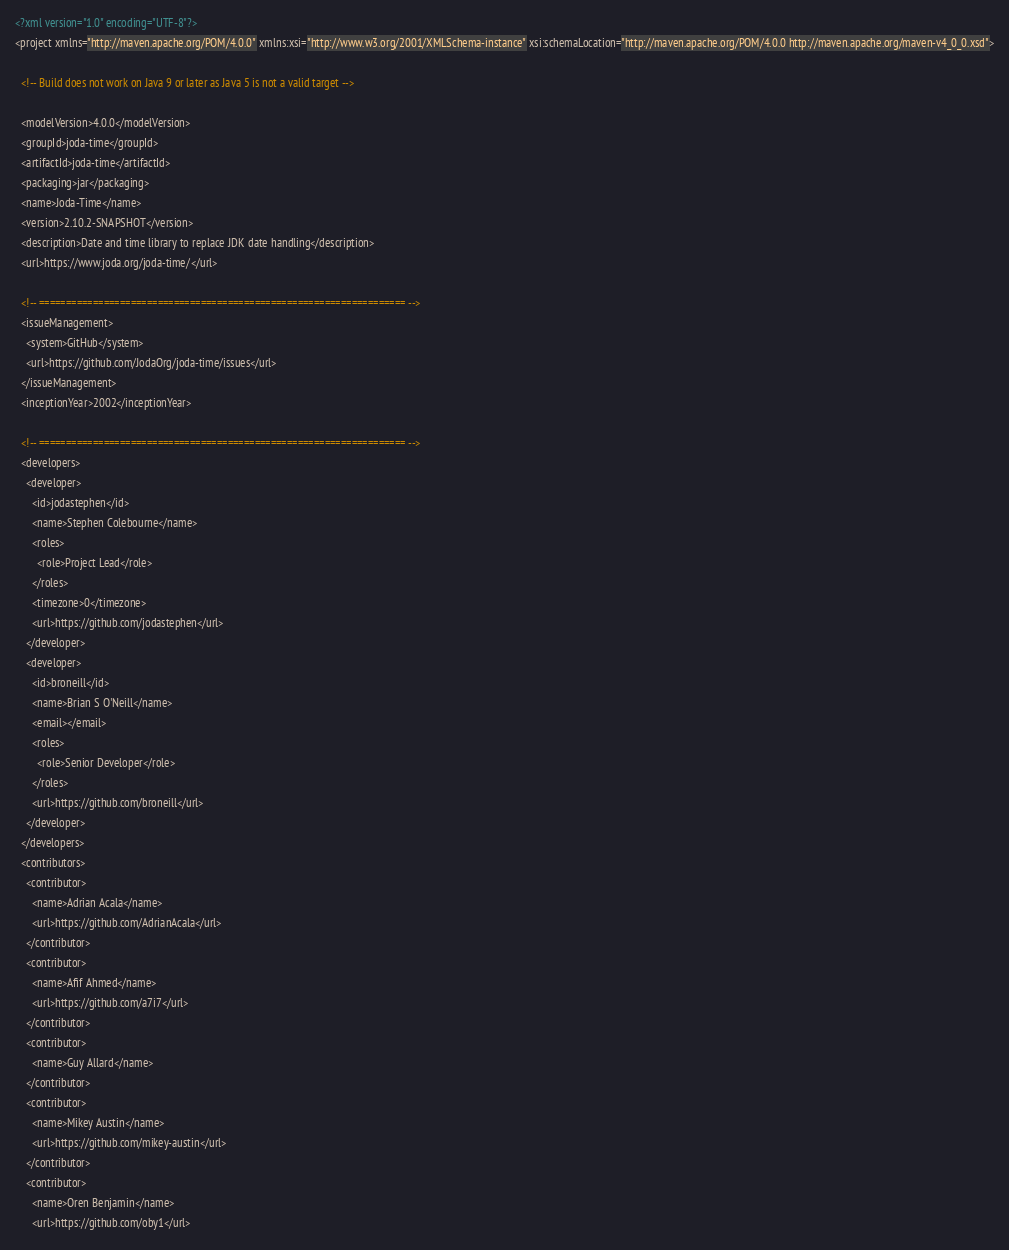<code> <loc_0><loc_0><loc_500><loc_500><_XML_><?xml version="1.0" encoding="UTF-8"?>
<project xmlns="http://maven.apache.org/POM/4.0.0" xmlns:xsi="http://www.w3.org/2001/XMLSchema-instance" xsi:schemaLocation="http://maven.apache.org/POM/4.0.0 http://maven.apache.org/maven-v4_0_0.xsd">

  <!-- Build does not work on Java 9 or later as Java 5 is not a valid target -->

  <modelVersion>4.0.0</modelVersion>
  <groupId>joda-time</groupId>
  <artifactId>joda-time</artifactId>
  <packaging>jar</packaging>
  <name>Joda-Time</name>
  <version>2.10.2-SNAPSHOT</version>
  <description>Date and time library to replace JDK date handling</description>
  <url>https://www.joda.org/joda-time/</url>

  <!-- ==================================================================== -->
  <issueManagement>
    <system>GitHub</system>
    <url>https://github.com/JodaOrg/joda-time/issues</url>
  </issueManagement>
  <inceptionYear>2002</inceptionYear>

  <!-- ==================================================================== -->
  <developers>
    <developer>
      <id>jodastephen</id>
      <name>Stephen Colebourne</name>
      <roles>
        <role>Project Lead</role>
      </roles>
      <timezone>0</timezone>
      <url>https://github.com/jodastephen</url>
    </developer>
    <developer>
      <id>broneill</id>
      <name>Brian S O'Neill</name>
      <email></email>
      <roles>
        <role>Senior Developer</role>
      </roles>
      <url>https://github.com/broneill</url>
    </developer>
  </developers>
  <contributors>
    <contributor>
      <name>Adrian Acala</name>
      <url>https://github.com/AdrianAcala</url>
    </contributor>
    <contributor>
      <name>Afif Ahmed</name>
      <url>https://github.com/a7i7</url>
    </contributor>
    <contributor>
      <name>Guy Allard</name>
    </contributor>
    <contributor>
      <name>Mikey Austin</name>
      <url>https://github.com/mikey-austin</url>
    </contributor>
    <contributor>
      <name>Oren Benjamin</name>
      <url>https://github.com/oby1</url></code> 